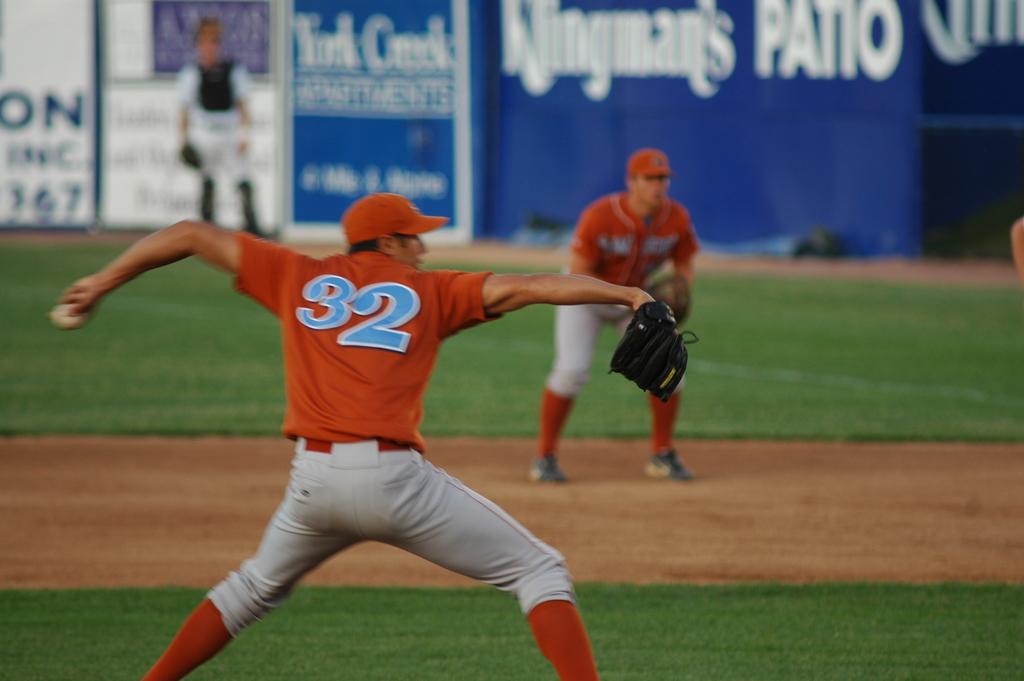What number is the pitcher?
Provide a short and direct response. 32. What word is written in all capital letters on the blue banner?
Provide a succinct answer. Patio. 